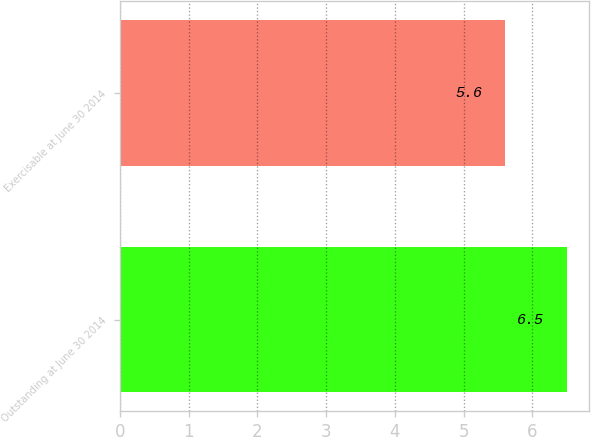<chart> <loc_0><loc_0><loc_500><loc_500><bar_chart><fcel>Outstanding at June 30 2014<fcel>Exercisable at June 30 2014<nl><fcel>6.5<fcel>5.6<nl></chart> 